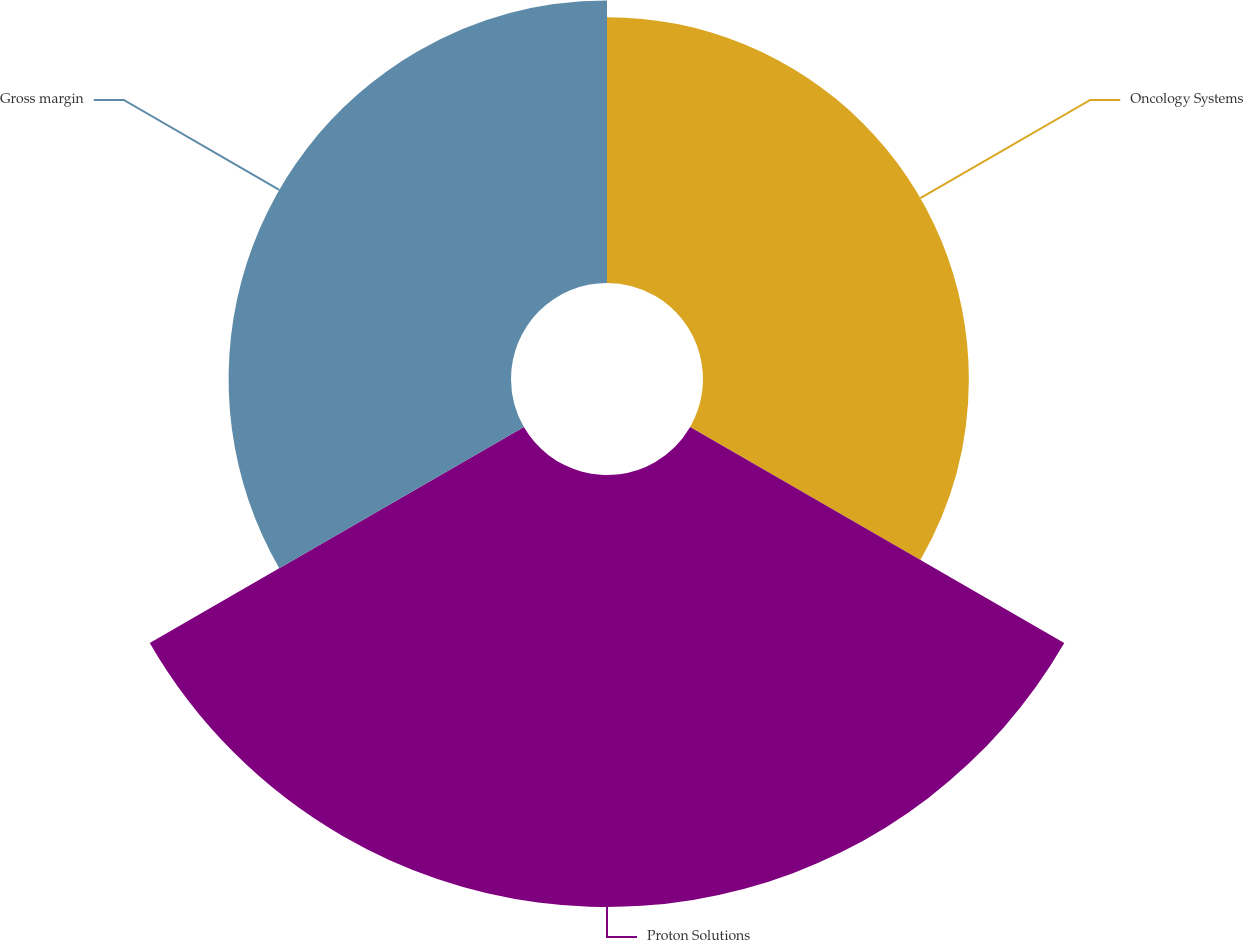Convert chart to OTSL. <chart><loc_0><loc_0><loc_500><loc_500><pie_chart><fcel>Oncology Systems<fcel>Proton Solutions<fcel>Gross margin<nl><fcel>27.12%<fcel>44.07%<fcel>28.81%<nl></chart> 